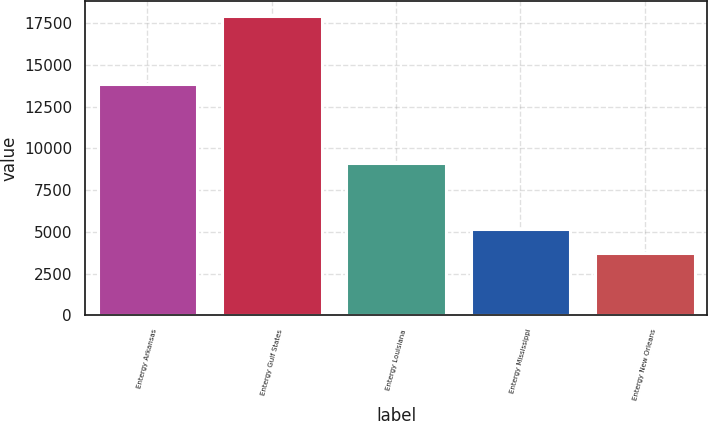Convert chart to OTSL. <chart><loc_0><loc_0><loc_500><loc_500><bar_chart><fcel>Entergy Arkansas<fcel>Entergy Gulf States<fcel>Entergy Louisiana<fcel>Entergy Mississippi<fcel>Entergy New Orleans<nl><fcel>13825<fcel>17932<fcel>9146<fcel>5146.6<fcel>3726<nl></chart> 